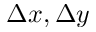Convert formula to latex. <formula><loc_0><loc_0><loc_500><loc_500>\Delta x , \Delta y</formula> 